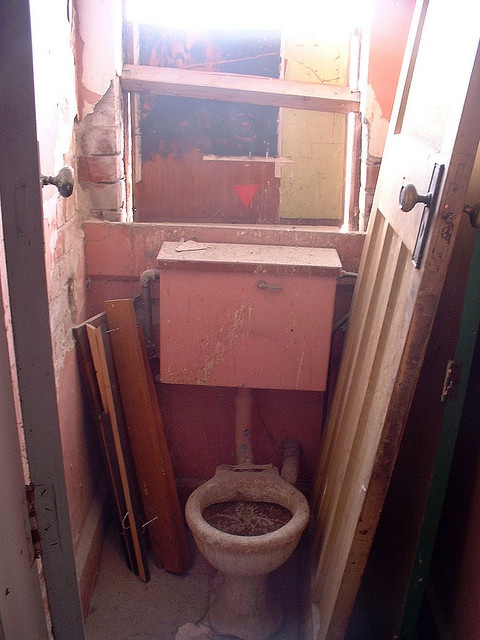Describe the objects in this image and their specific colors. I can see a toilet in purple, brown, maroon, and black tones in this image. 